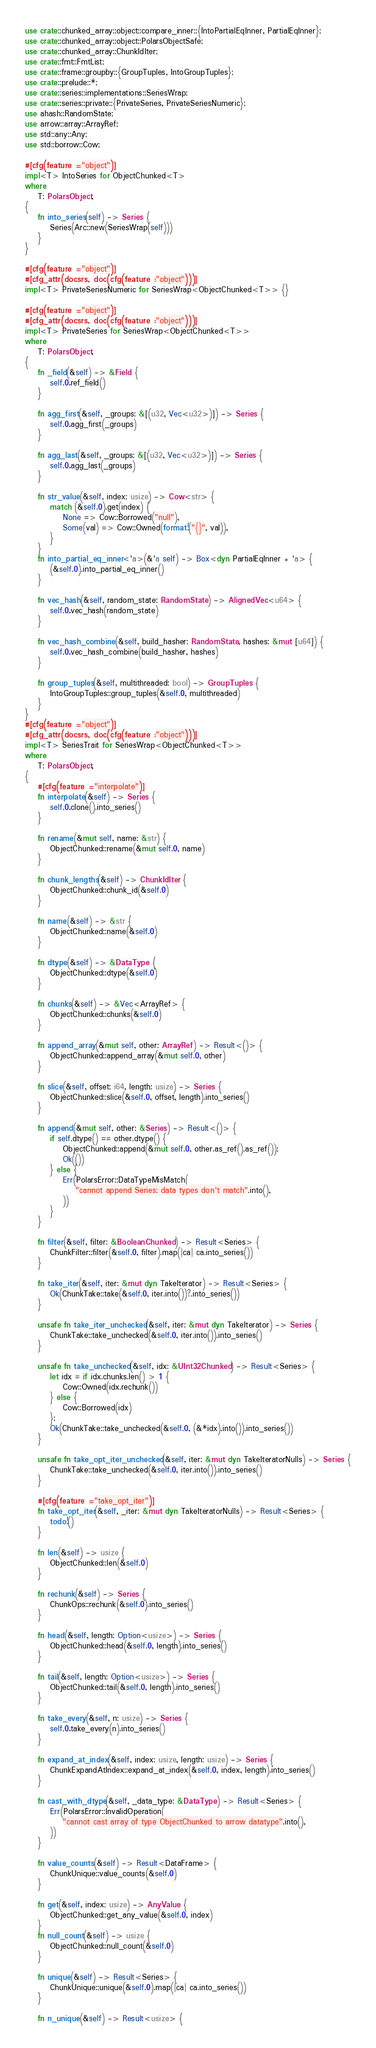Convert code to text. <code><loc_0><loc_0><loc_500><loc_500><_Rust_>use crate::chunked_array::object::compare_inner::{IntoPartialEqInner, PartialEqInner};
use crate::chunked_array::object::PolarsObjectSafe;
use crate::chunked_array::ChunkIdIter;
use crate::fmt::FmtList;
use crate::frame::groupby::{GroupTuples, IntoGroupTuples};
use crate::prelude::*;
use crate::series::implementations::SeriesWrap;
use crate::series::private::{PrivateSeries, PrivateSeriesNumeric};
use ahash::RandomState;
use arrow::array::ArrayRef;
use std::any::Any;
use std::borrow::Cow;

#[cfg(feature = "object")]
impl<T> IntoSeries for ObjectChunked<T>
where
    T: PolarsObject,
{
    fn into_series(self) -> Series {
        Series(Arc::new(SeriesWrap(self)))
    }
}

#[cfg(feature = "object")]
#[cfg_attr(docsrs, doc(cfg(feature = "object")))]
impl<T> PrivateSeriesNumeric for SeriesWrap<ObjectChunked<T>> {}

#[cfg(feature = "object")]
#[cfg_attr(docsrs, doc(cfg(feature = "object")))]
impl<T> PrivateSeries for SeriesWrap<ObjectChunked<T>>
where
    T: PolarsObject,
{
    fn _field(&self) -> &Field {
        self.0.ref_field()
    }

    fn agg_first(&self, _groups: &[(u32, Vec<u32>)]) -> Series {
        self.0.agg_first(_groups)
    }

    fn agg_last(&self, _groups: &[(u32, Vec<u32>)]) -> Series {
        self.0.agg_last(_groups)
    }

    fn str_value(&self, index: usize) -> Cow<str> {
        match (&self.0).get(index) {
            None => Cow::Borrowed("null"),
            Some(val) => Cow::Owned(format!("{}", val)),
        }
    }
    fn into_partial_eq_inner<'a>(&'a self) -> Box<dyn PartialEqInner + 'a> {
        (&self.0).into_partial_eq_inner()
    }

    fn vec_hash(&self, random_state: RandomState) -> AlignedVec<u64> {
        self.0.vec_hash(random_state)
    }

    fn vec_hash_combine(&self, build_hasher: RandomState, hashes: &mut [u64]) {
        self.0.vec_hash_combine(build_hasher, hashes)
    }

    fn group_tuples(&self, multithreaded: bool) -> GroupTuples {
        IntoGroupTuples::group_tuples(&self.0, multithreaded)
    }
}
#[cfg(feature = "object")]
#[cfg_attr(docsrs, doc(cfg(feature = "object")))]
impl<T> SeriesTrait for SeriesWrap<ObjectChunked<T>>
where
    T: PolarsObject,
{
    #[cfg(feature = "interpolate")]
    fn interpolate(&self) -> Series {
        self.0.clone().into_series()
    }

    fn rename(&mut self, name: &str) {
        ObjectChunked::rename(&mut self.0, name)
    }

    fn chunk_lengths(&self) -> ChunkIdIter {
        ObjectChunked::chunk_id(&self.0)
    }

    fn name(&self) -> &str {
        ObjectChunked::name(&self.0)
    }

    fn dtype(&self) -> &DataType {
        ObjectChunked::dtype(&self.0)
    }

    fn chunks(&self) -> &Vec<ArrayRef> {
        ObjectChunked::chunks(&self.0)
    }

    fn append_array(&mut self, other: ArrayRef) -> Result<()> {
        ObjectChunked::append_array(&mut self.0, other)
    }

    fn slice(&self, offset: i64, length: usize) -> Series {
        ObjectChunked::slice(&self.0, offset, length).into_series()
    }

    fn append(&mut self, other: &Series) -> Result<()> {
        if self.dtype() == other.dtype() {
            ObjectChunked::append(&mut self.0, other.as_ref().as_ref());
            Ok(())
        } else {
            Err(PolarsError::DataTypeMisMatch(
                "cannot append Series; data types don't match".into(),
            ))
        }
    }

    fn filter(&self, filter: &BooleanChunked) -> Result<Series> {
        ChunkFilter::filter(&self.0, filter).map(|ca| ca.into_series())
    }

    fn take_iter(&self, iter: &mut dyn TakeIterator) -> Result<Series> {
        Ok(ChunkTake::take(&self.0, iter.into())?.into_series())
    }

    unsafe fn take_iter_unchecked(&self, iter: &mut dyn TakeIterator) -> Series {
        ChunkTake::take_unchecked(&self.0, iter.into()).into_series()
    }

    unsafe fn take_unchecked(&self, idx: &UInt32Chunked) -> Result<Series> {
        let idx = if idx.chunks.len() > 1 {
            Cow::Owned(idx.rechunk())
        } else {
            Cow::Borrowed(idx)
        };
        Ok(ChunkTake::take_unchecked(&self.0, (&*idx).into()).into_series())
    }

    unsafe fn take_opt_iter_unchecked(&self, iter: &mut dyn TakeIteratorNulls) -> Series {
        ChunkTake::take_unchecked(&self.0, iter.into()).into_series()
    }

    #[cfg(feature = "take_opt_iter")]
    fn take_opt_iter(&self, _iter: &mut dyn TakeIteratorNulls) -> Result<Series> {
        todo!()
    }

    fn len(&self) -> usize {
        ObjectChunked::len(&self.0)
    }

    fn rechunk(&self) -> Series {
        ChunkOps::rechunk(&self.0).into_series()
    }

    fn head(&self, length: Option<usize>) -> Series {
        ObjectChunked::head(&self.0, length).into_series()
    }

    fn tail(&self, length: Option<usize>) -> Series {
        ObjectChunked::tail(&self.0, length).into_series()
    }

    fn take_every(&self, n: usize) -> Series {
        self.0.take_every(n).into_series()
    }

    fn expand_at_index(&self, index: usize, length: usize) -> Series {
        ChunkExpandAtIndex::expand_at_index(&self.0, index, length).into_series()
    }

    fn cast_with_dtype(&self, _data_type: &DataType) -> Result<Series> {
        Err(PolarsError::InvalidOperation(
            "cannot cast array of type ObjectChunked to arrow datatype".into(),
        ))
    }

    fn value_counts(&self) -> Result<DataFrame> {
        ChunkUnique::value_counts(&self.0)
    }

    fn get(&self, index: usize) -> AnyValue {
        ObjectChunked::get_any_value(&self.0, index)
    }
    fn null_count(&self) -> usize {
        ObjectChunked::null_count(&self.0)
    }

    fn unique(&self) -> Result<Series> {
        ChunkUnique::unique(&self.0).map(|ca| ca.into_series())
    }

    fn n_unique(&self) -> Result<usize> {</code> 